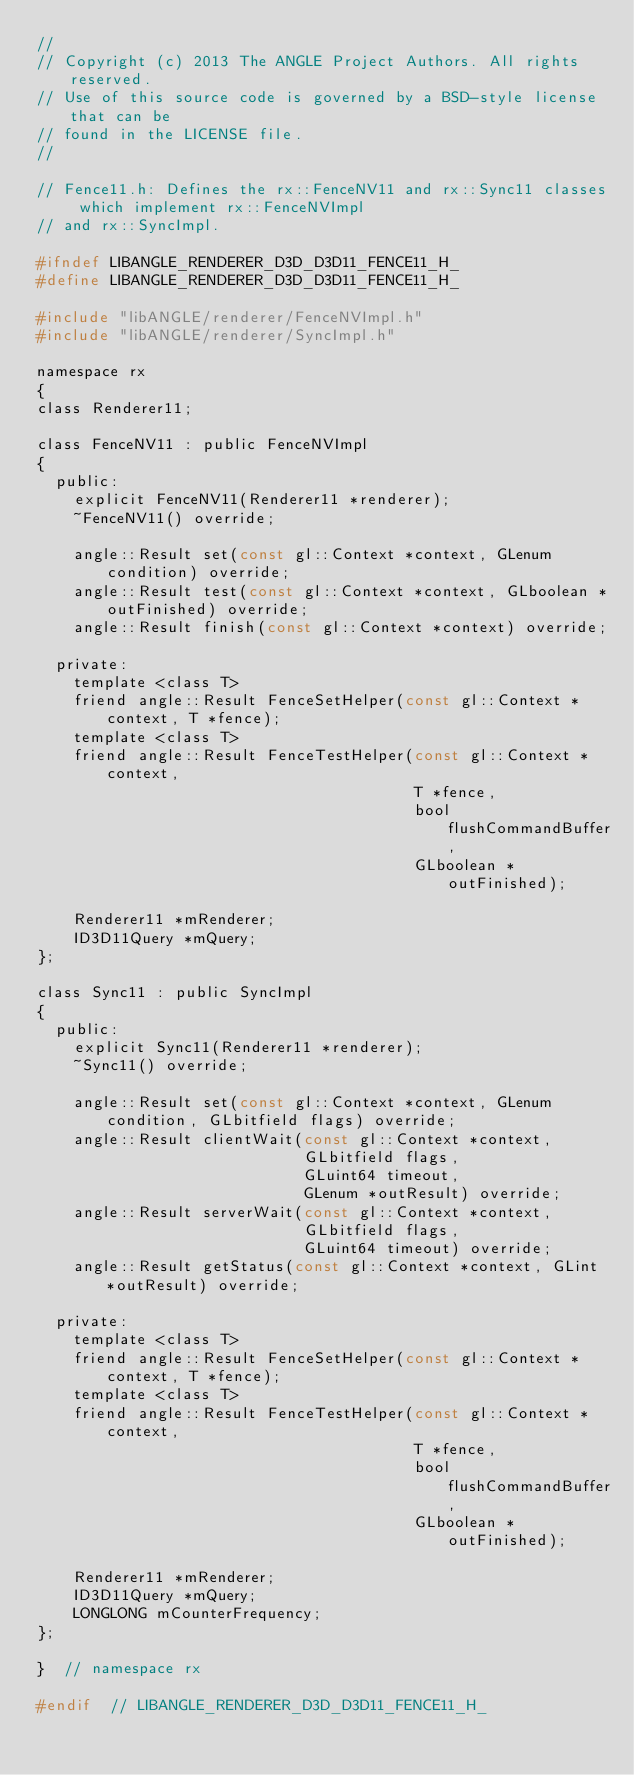<code> <loc_0><loc_0><loc_500><loc_500><_C_>//
// Copyright (c) 2013 The ANGLE Project Authors. All rights reserved.
// Use of this source code is governed by a BSD-style license that can be
// found in the LICENSE file.
//

// Fence11.h: Defines the rx::FenceNV11 and rx::Sync11 classes which implement rx::FenceNVImpl
// and rx::SyncImpl.

#ifndef LIBANGLE_RENDERER_D3D_D3D11_FENCE11_H_
#define LIBANGLE_RENDERER_D3D_D3D11_FENCE11_H_

#include "libANGLE/renderer/FenceNVImpl.h"
#include "libANGLE/renderer/SyncImpl.h"

namespace rx
{
class Renderer11;

class FenceNV11 : public FenceNVImpl
{
  public:
    explicit FenceNV11(Renderer11 *renderer);
    ~FenceNV11() override;

    angle::Result set(const gl::Context *context, GLenum condition) override;
    angle::Result test(const gl::Context *context, GLboolean *outFinished) override;
    angle::Result finish(const gl::Context *context) override;

  private:
    template <class T>
    friend angle::Result FenceSetHelper(const gl::Context *context, T *fence);
    template <class T>
    friend angle::Result FenceTestHelper(const gl::Context *context,
                                         T *fence,
                                         bool flushCommandBuffer,
                                         GLboolean *outFinished);

    Renderer11 *mRenderer;
    ID3D11Query *mQuery;
};

class Sync11 : public SyncImpl
{
  public:
    explicit Sync11(Renderer11 *renderer);
    ~Sync11() override;

    angle::Result set(const gl::Context *context, GLenum condition, GLbitfield flags) override;
    angle::Result clientWait(const gl::Context *context,
                             GLbitfield flags,
                             GLuint64 timeout,
                             GLenum *outResult) override;
    angle::Result serverWait(const gl::Context *context,
                             GLbitfield flags,
                             GLuint64 timeout) override;
    angle::Result getStatus(const gl::Context *context, GLint *outResult) override;

  private:
    template <class T>
    friend angle::Result FenceSetHelper(const gl::Context *context, T *fence);
    template <class T>
    friend angle::Result FenceTestHelper(const gl::Context *context,
                                         T *fence,
                                         bool flushCommandBuffer,
                                         GLboolean *outFinished);

    Renderer11 *mRenderer;
    ID3D11Query *mQuery;
    LONGLONG mCounterFrequency;
};

}  // namespace rx

#endif  // LIBANGLE_RENDERER_D3D_D3D11_FENCE11_H_
</code> 